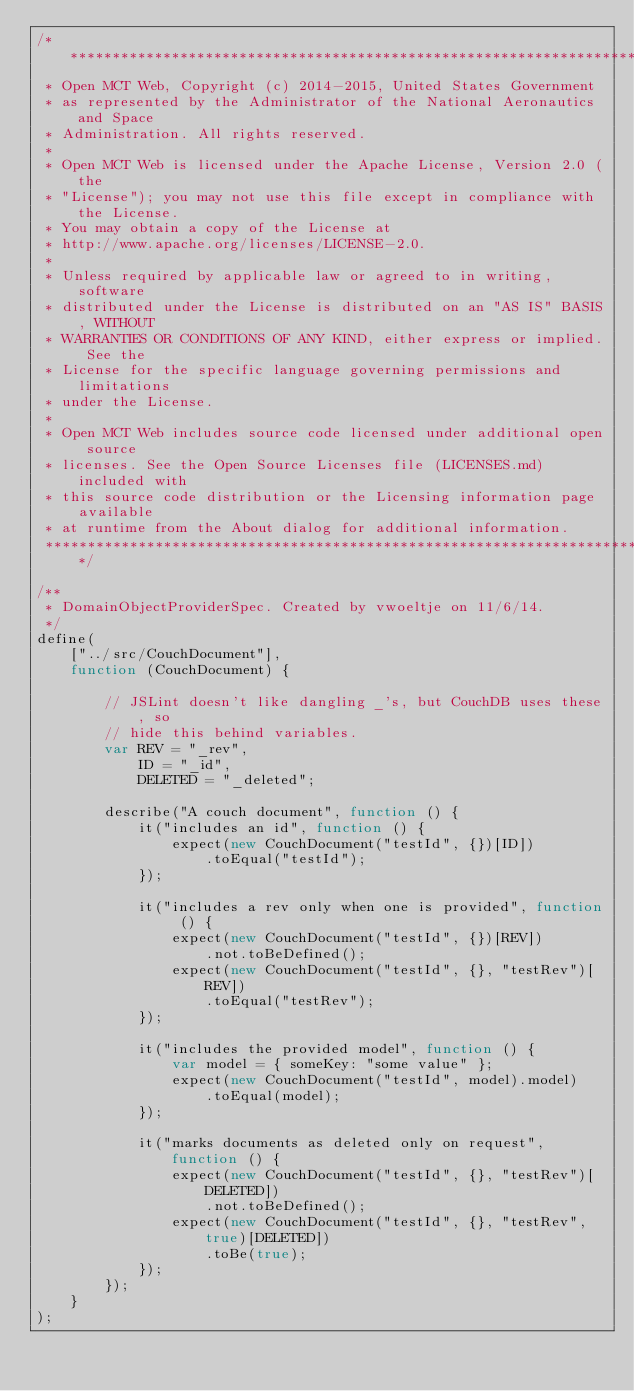Convert code to text. <code><loc_0><loc_0><loc_500><loc_500><_JavaScript_>/*****************************************************************************
 * Open MCT Web, Copyright (c) 2014-2015, United States Government
 * as represented by the Administrator of the National Aeronautics and Space
 * Administration. All rights reserved.
 *
 * Open MCT Web is licensed under the Apache License, Version 2.0 (the
 * "License"); you may not use this file except in compliance with the License.
 * You may obtain a copy of the License at
 * http://www.apache.org/licenses/LICENSE-2.0.
 *
 * Unless required by applicable law or agreed to in writing, software
 * distributed under the License is distributed on an "AS IS" BASIS, WITHOUT
 * WARRANTIES OR CONDITIONS OF ANY KIND, either express or implied. See the
 * License for the specific language governing permissions and limitations
 * under the License.
 *
 * Open MCT Web includes source code licensed under additional open source
 * licenses. See the Open Source Licenses file (LICENSES.md) included with
 * this source code distribution or the Licensing information page available
 * at runtime from the About dialog for additional information.
 *****************************************************************************/

/**
 * DomainObjectProviderSpec. Created by vwoeltje on 11/6/14.
 */
define(
    ["../src/CouchDocument"],
    function (CouchDocument) {

        // JSLint doesn't like dangling _'s, but CouchDB uses these, so
        // hide this behind variables.
        var REV = "_rev",
            ID = "_id",
            DELETED = "_deleted";

        describe("A couch document", function () {
            it("includes an id", function () {
                expect(new CouchDocument("testId", {})[ID])
                    .toEqual("testId");
            });

            it("includes a rev only when one is provided", function () {
                expect(new CouchDocument("testId", {})[REV])
                    .not.toBeDefined();
                expect(new CouchDocument("testId", {}, "testRev")[REV])
                    .toEqual("testRev");
            });

            it("includes the provided model", function () {
                var model = { someKey: "some value" };
                expect(new CouchDocument("testId", model).model)
                    .toEqual(model);
            });

            it("marks documents as deleted only on request", function () {
                expect(new CouchDocument("testId", {}, "testRev")[DELETED])
                    .not.toBeDefined();
                expect(new CouchDocument("testId", {}, "testRev", true)[DELETED])
                    .toBe(true);
            });
        });
    }
);</code> 